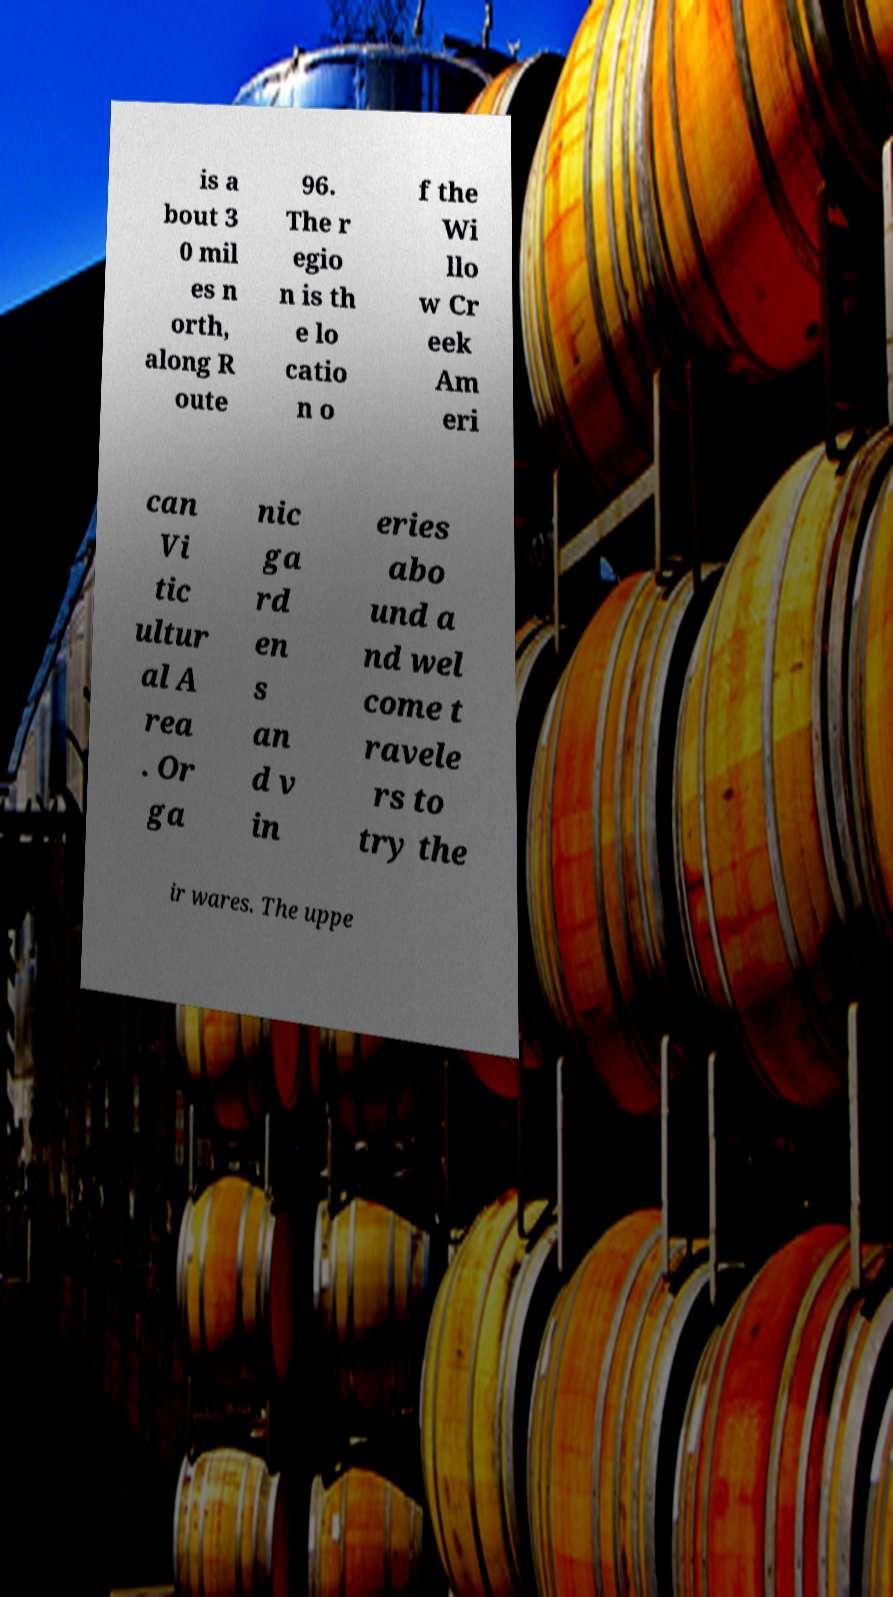For documentation purposes, I need the text within this image transcribed. Could you provide that? is a bout 3 0 mil es n orth, along R oute 96. The r egio n is th e lo catio n o f the Wi llo w Cr eek Am eri can Vi tic ultur al A rea . Or ga nic ga rd en s an d v in eries abo und a nd wel come t ravele rs to try the ir wares. The uppe 